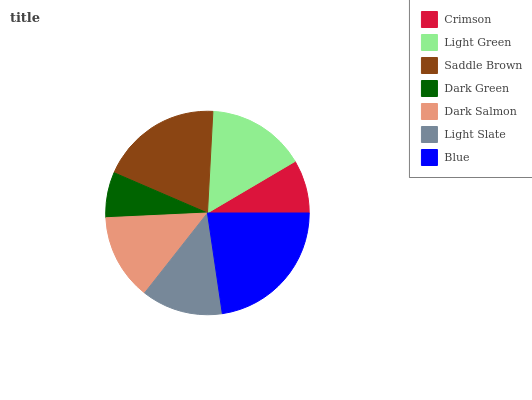Is Dark Green the minimum?
Answer yes or no. Yes. Is Blue the maximum?
Answer yes or no. Yes. Is Light Green the minimum?
Answer yes or no. No. Is Light Green the maximum?
Answer yes or no. No. Is Light Green greater than Crimson?
Answer yes or no. Yes. Is Crimson less than Light Green?
Answer yes or no. Yes. Is Crimson greater than Light Green?
Answer yes or no. No. Is Light Green less than Crimson?
Answer yes or no. No. Is Dark Salmon the high median?
Answer yes or no. Yes. Is Dark Salmon the low median?
Answer yes or no. Yes. Is Crimson the high median?
Answer yes or no. No. Is Light Slate the low median?
Answer yes or no. No. 